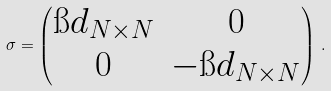<formula> <loc_0><loc_0><loc_500><loc_500>\sigma = \begin{pmatrix} \i d _ { N \times N } & 0 \\ 0 & - \i d _ { N \times N } \end{pmatrix} \, .</formula> 